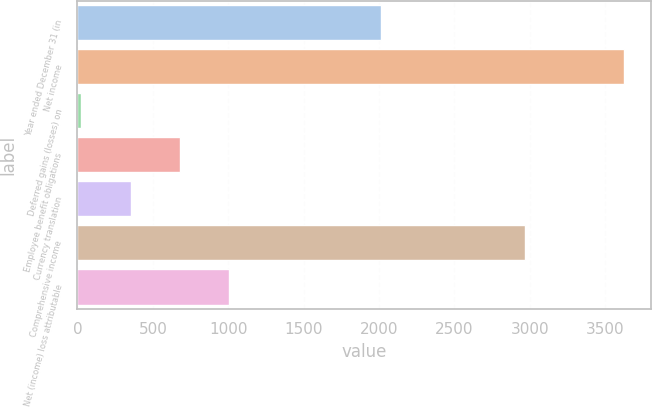Convert chart. <chart><loc_0><loc_0><loc_500><loc_500><bar_chart><fcel>Year ended December 31 (in<fcel>Net income<fcel>Deferred gains (losses) on<fcel>Employee benefit obligations<fcel>Currency translation<fcel>Comprehensive income<fcel>Net (income) loss attributable<nl><fcel>2014<fcel>3626.4<fcel>25<fcel>679.4<fcel>352.2<fcel>2972<fcel>1006.6<nl></chart> 